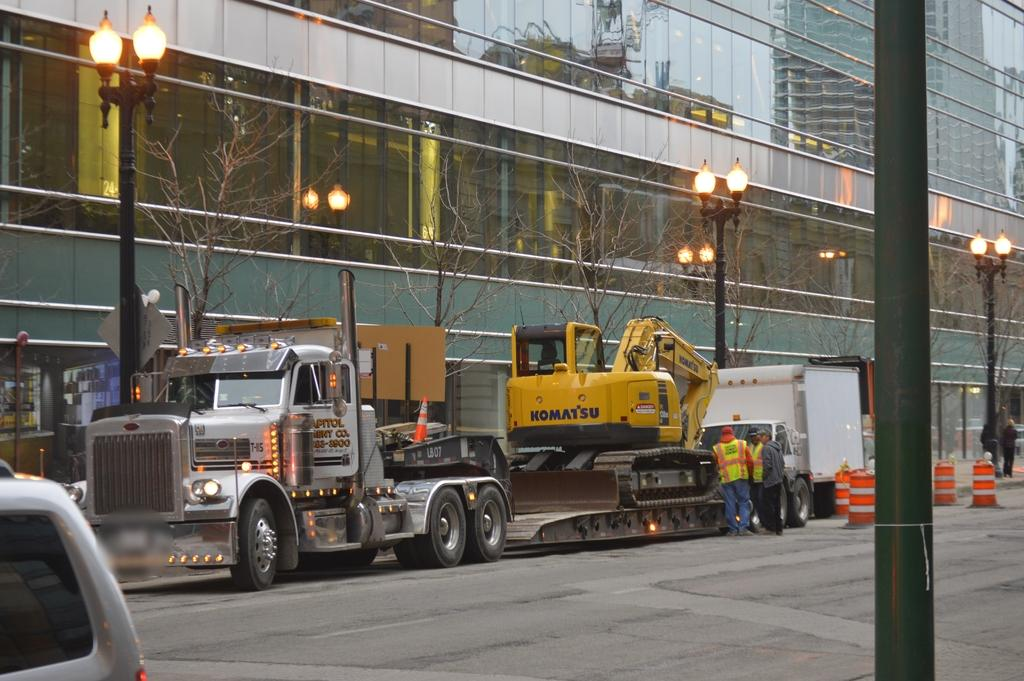What is the main structure in the image? There is a big building in the image. What else can be seen in the image besides the building? There are electrical poles, people, a lorry, and a mini truck visible in the image. What is the purpose of the electrical poles in the image? The electrical poles have lights, which suggests they are used for providing illumination. What type of vehicles are present in the image? There is a lorry and a mini truck in the image. What is the setting of the image? There is a road in the image, which suggests it is an outdoor scene. What type of yam is being used to pave the road in the image? There is no yam present in the image; the road is paved with a different material. How many feet are visible on the people in the image? The image does not provide a clear view of the people's feet, so it is not possible to determine the number of feet visible. 